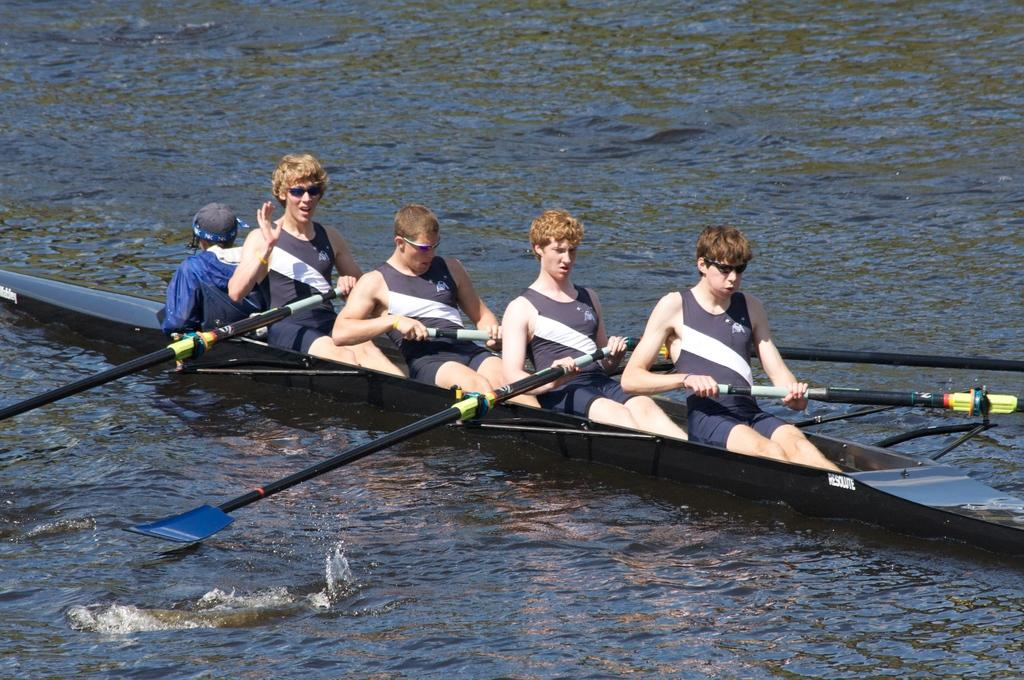What is happening in the image? There are people in the image, and they are rowing a boat. Where is the boat located? The boat is on the water. What type of adjustment can be seen on the button in the image? There is no button present in the image; it features people rowing a boat on the water. 